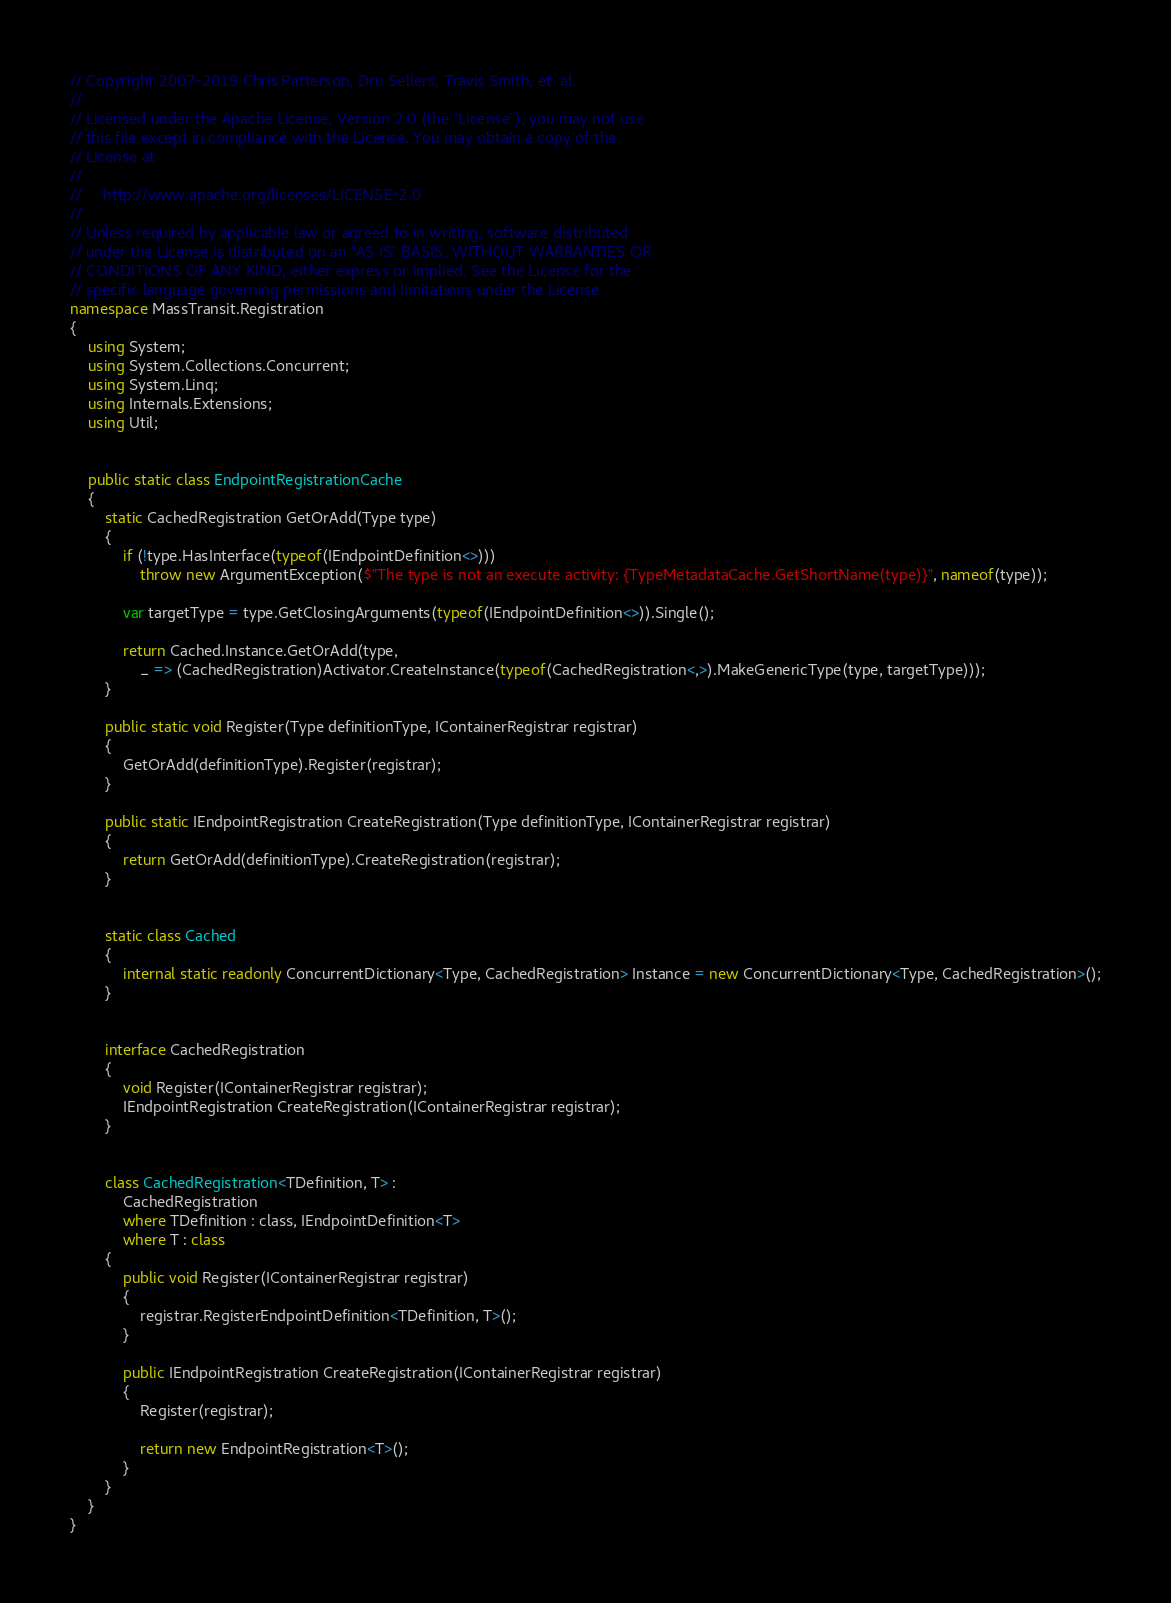Convert code to text. <code><loc_0><loc_0><loc_500><loc_500><_C#_>// Copyright 2007-2019 Chris Patterson, Dru Sellers, Travis Smith, et. al.
//
// Licensed under the Apache License, Version 2.0 (the "License"); you may not use
// this file except in compliance with the License. You may obtain a copy of the
// License at
//
//     http://www.apache.org/licenses/LICENSE-2.0
//
// Unless required by applicable law or agreed to in writing, software distributed
// under the License is distributed on an "AS IS" BASIS, WITHOUT WARRANTIES OR
// CONDITIONS OF ANY KIND, either express or implied. See the License for the
// specific language governing permissions and limitations under the License.
namespace MassTransit.Registration
{
    using System;
    using System.Collections.Concurrent;
    using System.Linq;
    using Internals.Extensions;
    using Util;


    public static class EndpointRegistrationCache
    {
        static CachedRegistration GetOrAdd(Type type)
        {
            if (!type.HasInterface(typeof(IEndpointDefinition<>)))
                throw new ArgumentException($"The type is not an execute activity: {TypeMetadataCache.GetShortName(type)}", nameof(type));

            var targetType = type.GetClosingArguments(typeof(IEndpointDefinition<>)).Single();

            return Cached.Instance.GetOrAdd(type,
                _ => (CachedRegistration)Activator.CreateInstance(typeof(CachedRegistration<,>).MakeGenericType(type, targetType)));
        }

        public static void Register(Type definitionType, IContainerRegistrar registrar)
        {
            GetOrAdd(definitionType).Register(registrar);
        }

        public static IEndpointRegistration CreateRegistration(Type definitionType, IContainerRegistrar registrar)
        {
            return GetOrAdd(definitionType).CreateRegistration(registrar);
        }


        static class Cached
        {
            internal static readonly ConcurrentDictionary<Type, CachedRegistration> Instance = new ConcurrentDictionary<Type, CachedRegistration>();
        }


        interface CachedRegistration
        {
            void Register(IContainerRegistrar registrar);
            IEndpointRegistration CreateRegistration(IContainerRegistrar registrar);
        }


        class CachedRegistration<TDefinition, T> :
            CachedRegistration
            where TDefinition : class, IEndpointDefinition<T>
            where T : class
        {
            public void Register(IContainerRegistrar registrar)
            {
                registrar.RegisterEndpointDefinition<TDefinition, T>();
            }

            public IEndpointRegistration CreateRegistration(IContainerRegistrar registrar)
            {
                Register(registrar);

                return new EndpointRegistration<T>();
            }
        }
    }
}
</code> 